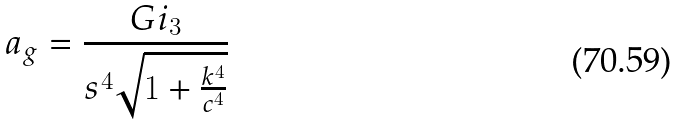<formula> <loc_0><loc_0><loc_500><loc_500>a _ { g } = \frac { G i _ { 3 } } { s ^ { 4 } \sqrt { 1 + \frac { k ^ { 4 } } { c ^ { 4 } } } }</formula> 